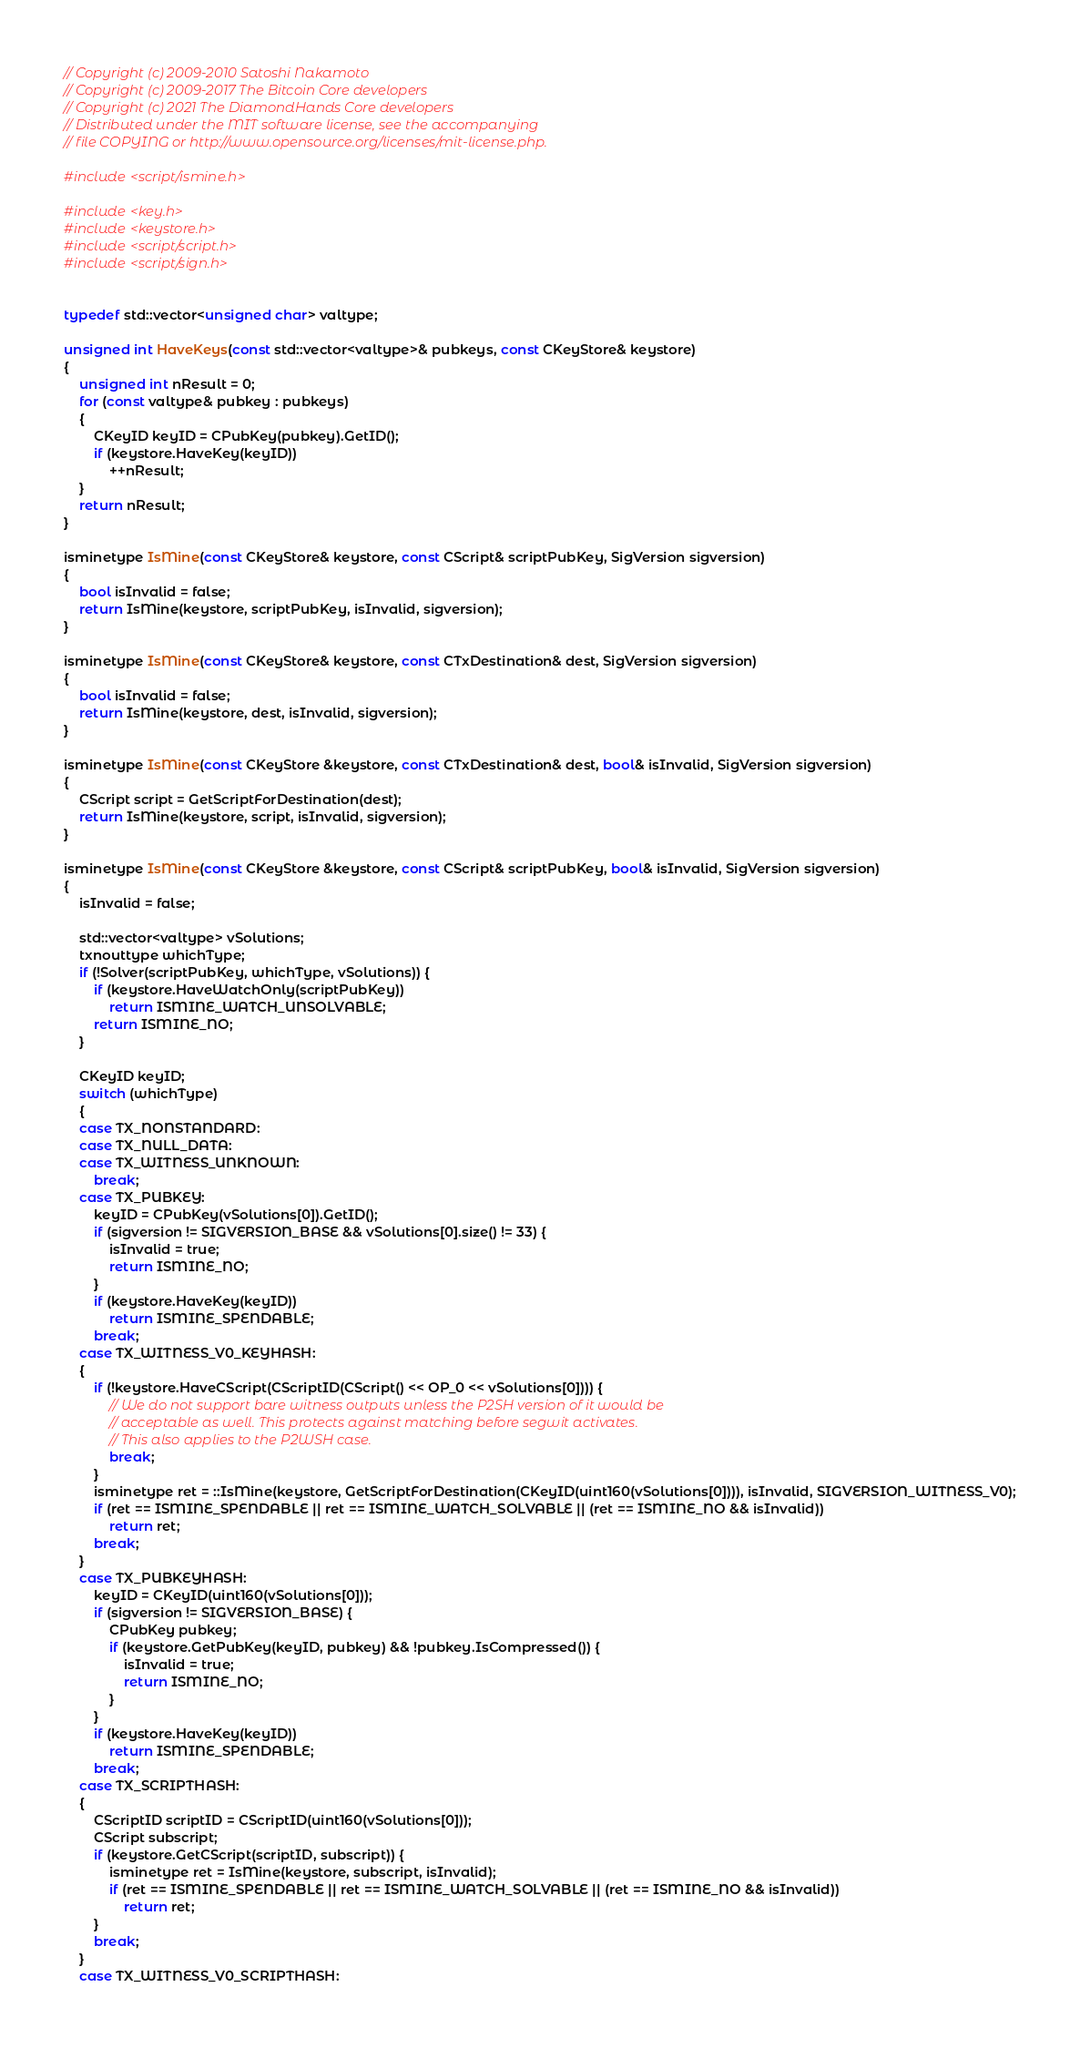Convert code to text. <code><loc_0><loc_0><loc_500><loc_500><_C++_>// Copyright (c) 2009-2010 Satoshi Nakamoto
// Copyright (c) 2009-2017 The Bitcoin Core developers
// Copyright (c) 2021 The DiamondHands Core developers
// Distributed under the MIT software license, see the accompanying
// file COPYING or http://www.opensource.org/licenses/mit-license.php.

#include <script/ismine.h>

#include <key.h>
#include <keystore.h>
#include <script/script.h>
#include <script/sign.h>


typedef std::vector<unsigned char> valtype;

unsigned int HaveKeys(const std::vector<valtype>& pubkeys, const CKeyStore& keystore)
{
    unsigned int nResult = 0;
    for (const valtype& pubkey : pubkeys)
    {
        CKeyID keyID = CPubKey(pubkey).GetID();
        if (keystore.HaveKey(keyID))
            ++nResult;
    }
    return nResult;
}

isminetype IsMine(const CKeyStore& keystore, const CScript& scriptPubKey, SigVersion sigversion)
{
    bool isInvalid = false;
    return IsMine(keystore, scriptPubKey, isInvalid, sigversion);
}

isminetype IsMine(const CKeyStore& keystore, const CTxDestination& dest, SigVersion sigversion)
{
    bool isInvalid = false;
    return IsMine(keystore, dest, isInvalid, sigversion);
}

isminetype IsMine(const CKeyStore &keystore, const CTxDestination& dest, bool& isInvalid, SigVersion sigversion)
{
    CScript script = GetScriptForDestination(dest);
    return IsMine(keystore, script, isInvalid, sigversion);
}

isminetype IsMine(const CKeyStore &keystore, const CScript& scriptPubKey, bool& isInvalid, SigVersion sigversion)
{
    isInvalid = false;

    std::vector<valtype> vSolutions;
    txnouttype whichType;
    if (!Solver(scriptPubKey, whichType, vSolutions)) {
        if (keystore.HaveWatchOnly(scriptPubKey))
            return ISMINE_WATCH_UNSOLVABLE;
        return ISMINE_NO;
    }

    CKeyID keyID;
    switch (whichType)
    {
    case TX_NONSTANDARD:
    case TX_NULL_DATA:
    case TX_WITNESS_UNKNOWN:
        break;
    case TX_PUBKEY:
        keyID = CPubKey(vSolutions[0]).GetID();
        if (sigversion != SIGVERSION_BASE && vSolutions[0].size() != 33) {
            isInvalid = true;
            return ISMINE_NO;
        }
        if (keystore.HaveKey(keyID))
            return ISMINE_SPENDABLE;
        break;
    case TX_WITNESS_V0_KEYHASH:
    {
        if (!keystore.HaveCScript(CScriptID(CScript() << OP_0 << vSolutions[0]))) {
            // We do not support bare witness outputs unless the P2SH version of it would be
            // acceptable as well. This protects against matching before segwit activates.
            // This also applies to the P2WSH case.
            break;
        }
        isminetype ret = ::IsMine(keystore, GetScriptForDestination(CKeyID(uint160(vSolutions[0]))), isInvalid, SIGVERSION_WITNESS_V0);
        if (ret == ISMINE_SPENDABLE || ret == ISMINE_WATCH_SOLVABLE || (ret == ISMINE_NO && isInvalid))
            return ret;
        break;
    }
    case TX_PUBKEYHASH:
        keyID = CKeyID(uint160(vSolutions[0]));
        if (sigversion != SIGVERSION_BASE) {
            CPubKey pubkey;
            if (keystore.GetPubKey(keyID, pubkey) && !pubkey.IsCompressed()) {
                isInvalid = true;
                return ISMINE_NO;
            }
        }
        if (keystore.HaveKey(keyID))
            return ISMINE_SPENDABLE;
        break;
    case TX_SCRIPTHASH:
    {
        CScriptID scriptID = CScriptID(uint160(vSolutions[0]));
        CScript subscript;
        if (keystore.GetCScript(scriptID, subscript)) {
            isminetype ret = IsMine(keystore, subscript, isInvalid);
            if (ret == ISMINE_SPENDABLE || ret == ISMINE_WATCH_SOLVABLE || (ret == ISMINE_NO && isInvalid))
                return ret;
        }
        break;
    }
    case TX_WITNESS_V0_SCRIPTHASH:</code> 